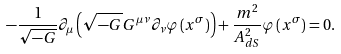Convert formula to latex. <formula><loc_0><loc_0><loc_500><loc_500>- \frac { 1 } { \sqrt { - G } } \partial _ { \mu } \left ( \sqrt { - G } G ^ { \mu \nu } \partial _ { \nu } \varphi \left ( x ^ { \sigma } \right ) \right ) + \frac { m ^ { 2 } } { A ^ { 2 } _ { d S } } \varphi \left ( x ^ { \sigma } \right ) = 0 .</formula> 